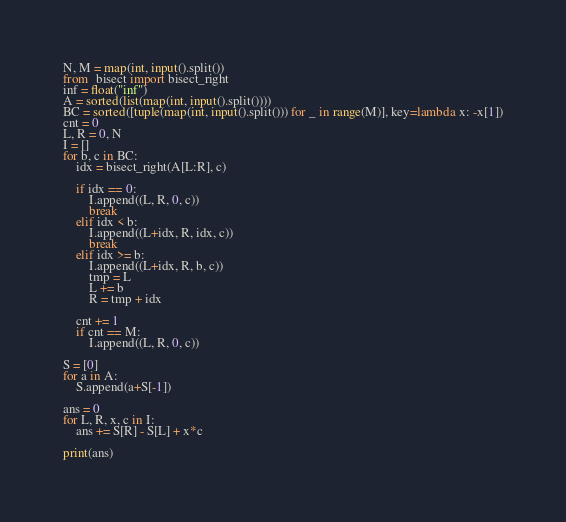<code> <loc_0><loc_0><loc_500><loc_500><_Python_>N, M = map(int, input().split())
from  bisect import bisect_right
inf = float("inf")
A = sorted(list(map(int, input().split())))
BC = sorted([tuple(map(int, input().split())) for _ in range(M)], key=lambda x: -x[1])
cnt = 0
L, R = 0, N
I = []
for b, c in BC:
    idx = bisect_right(A[L:R], c)

    if idx == 0:
        I.append((L, R, 0, c))
        break
    elif idx < b:
        I.append((L+idx, R, idx, c))
        break
    elif idx >= b:
        I.append((L+idx, R, b, c))
        tmp = L
        L += b
        R = tmp + idx

    cnt += 1
    if cnt == M:
        I.append((L, R, 0, c))

S = [0]
for a in A:
    S.append(a+S[-1])

ans = 0
for L, R, x, c in I:
    ans += S[R] - S[L] + x*c

print(ans)


</code> 